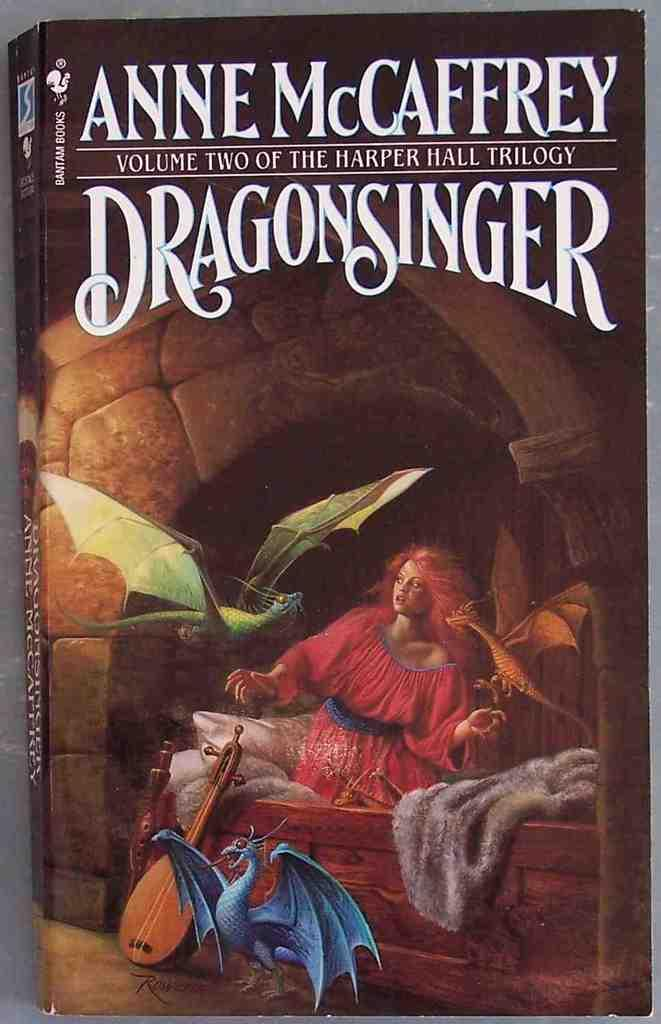<image>
Render a clear and concise summary of the photo. Book cover for Dragonsinger with a woman and three dragons. 